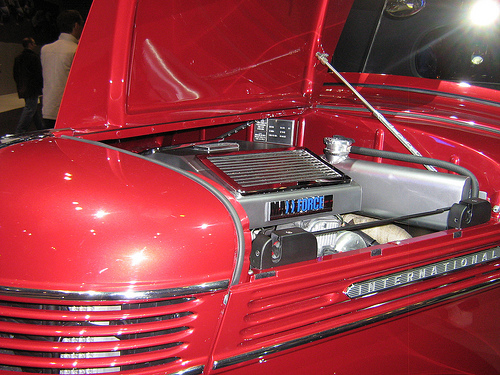<image>
Is the radiator in front of the engine? Yes. The radiator is positioned in front of the engine, appearing closer to the camera viewpoint. 